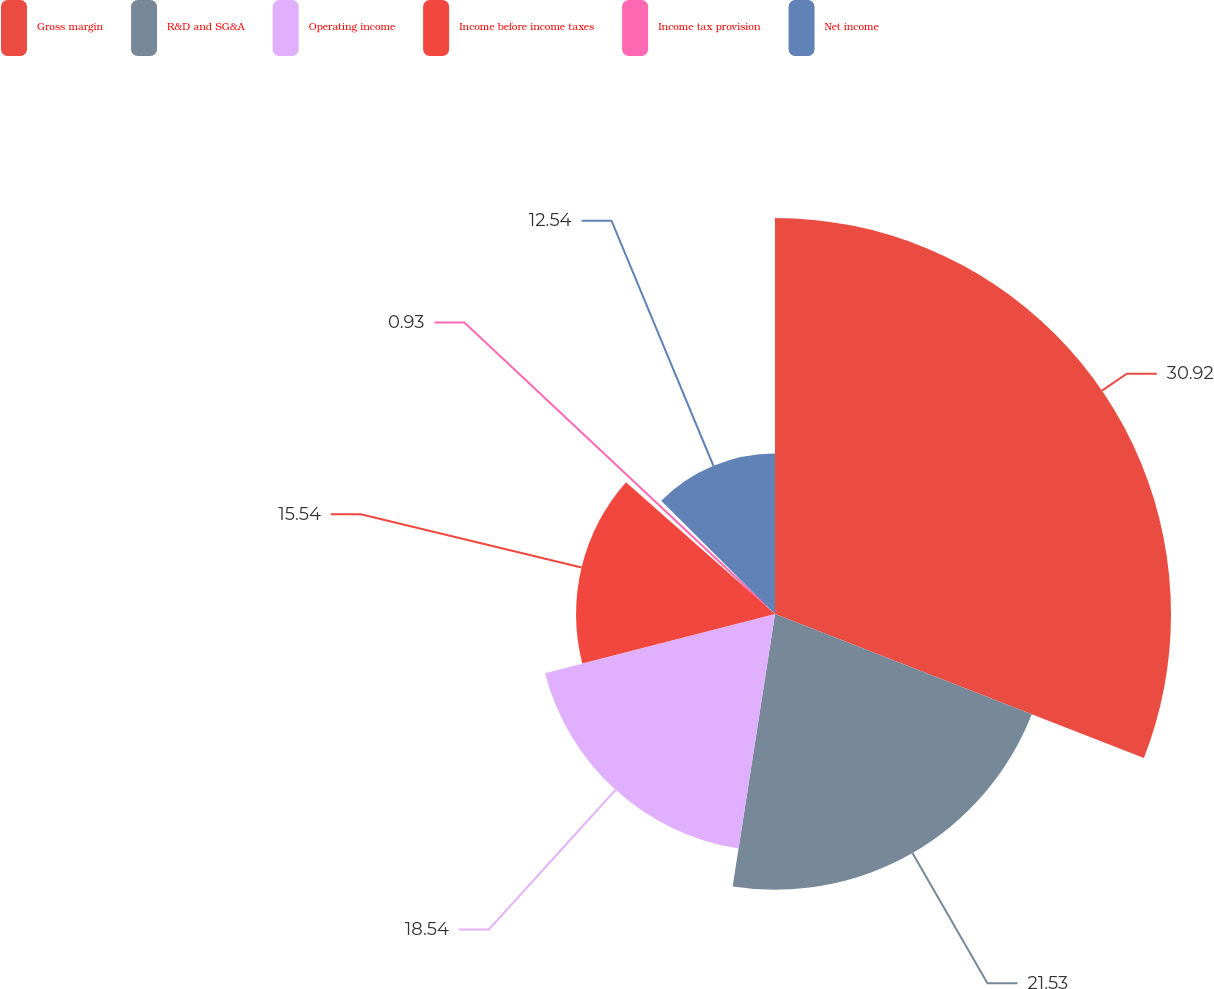<chart> <loc_0><loc_0><loc_500><loc_500><pie_chart><fcel>Gross margin<fcel>R&D and SG&A<fcel>Operating income<fcel>Income before income taxes<fcel>Income tax provision<fcel>Net income<nl><fcel>30.93%<fcel>21.53%<fcel>18.54%<fcel>15.54%<fcel>0.93%<fcel>12.54%<nl></chart> 